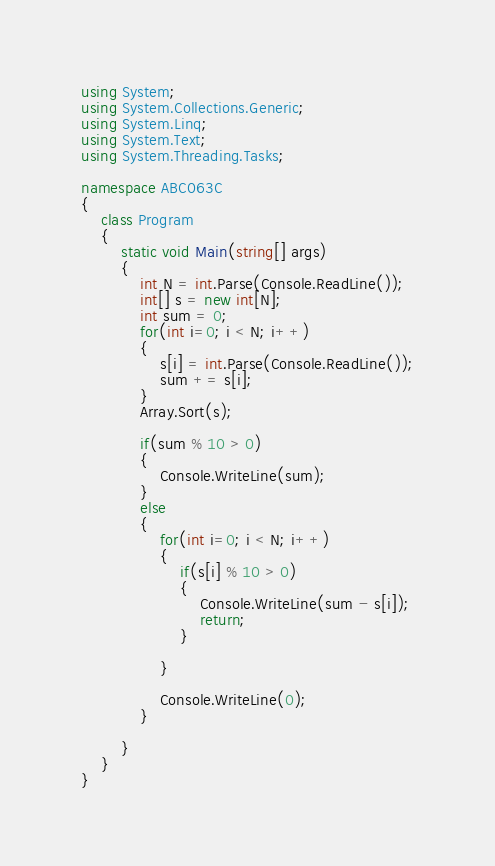Convert code to text. <code><loc_0><loc_0><loc_500><loc_500><_C#_>using System;
using System.Collections.Generic;
using System.Linq;
using System.Text;
using System.Threading.Tasks;

namespace ABC063C
{
    class Program
    {
        static void Main(string[] args)
        {
            int N = int.Parse(Console.ReadLine());
            int[] s = new int[N];
            int sum = 0;
            for(int i=0; i < N; i++)
            {
                s[i] = int.Parse(Console.ReadLine());
                sum += s[i];
            }
            Array.Sort(s);

            if(sum % 10 > 0)
            {
                Console.WriteLine(sum);
            }
            else
            {
                for(int i=0; i < N; i++)
                {
                    if(s[i] % 10 > 0)
                    {
                        Console.WriteLine(sum - s[i]);
                        return;
                    }

                }

                Console.WriteLine(0);
            }

        }
    }
}
</code> 